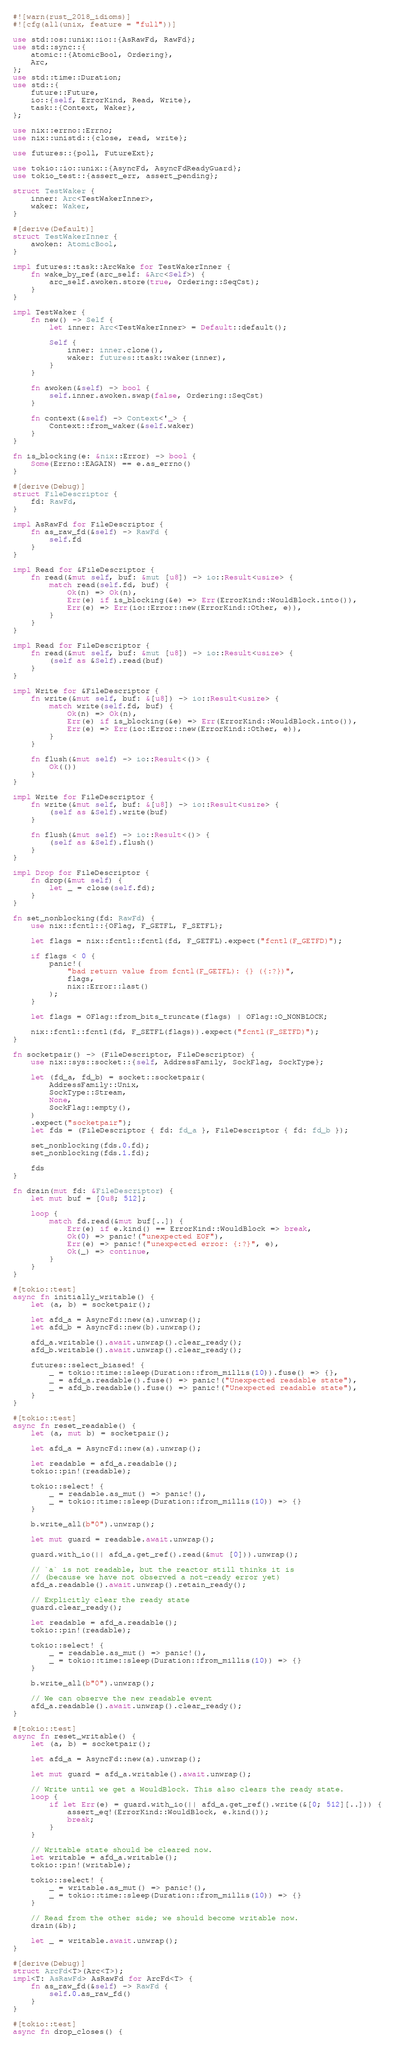Convert code to text. <code><loc_0><loc_0><loc_500><loc_500><_Rust_>#![warn(rust_2018_idioms)]
#![cfg(all(unix, feature = "full"))]

use std::os::unix::io::{AsRawFd, RawFd};
use std::sync::{
    atomic::{AtomicBool, Ordering},
    Arc,
};
use std::time::Duration;
use std::{
    future::Future,
    io::{self, ErrorKind, Read, Write},
    task::{Context, Waker},
};

use nix::errno::Errno;
use nix::unistd::{close, read, write};

use futures::{poll, FutureExt};

use tokio::io::unix::{AsyncFd, AsyncFdReadyGuard};
use tokio_test::{assert_err, assert_pending};

struct TestWaker {
    inner: Arc<TestWakerInner>,
    waker: Waker,
}

#[derive(Default)]
struct TestWakerInner {
    awoken: AtomicBool,
}

impl futures::task::ArcWake for TestWakerInner {
    fn wake_by_ref(arc_self: &Arc<Self>) {
        arc_self.awoken.store(true, Ordering::SeqCst);
    }
}

impl TestWaker {
    fn new() -> Self {
        let inner: Arc<TestWakerInner> = Default::default();

        Self {
            inner: inner.clone(),
            waker: futures::task::waker(inner),
        }
    }

    fn awoken(&self) -> bool {
        self.inner.awoken.swap(false, Ordering::SeqCst)
    }

    fn context(&self) -> Context<'_> {
        Context::from_waker(&self.waker)
    }
}

fn is_blocking(e: &nix::Error) -> bool {
    Some(Errno::EAGAIN) == e.as_errno()
}

#[derive(Debug)]
struct FileDescriptor {
    fd: RawFd,
}

impl AsRawFd for FileDescriptor {
    fn as_raw_fd(&self) -> RawFd {
        self.fd
    }
}

impl Read for &FileDescriptor {
    fn read(&mut self, buf: &mut [u8]) -> io::Result<usize> {
        match read(self.fd, buf) {
            Ok(n) => Ok(n),
            Err(e) if is_blocking(&e) => Err(ErrorKind::WouldBlock.into()),
            Err(e) => Err(io::Error::new(ErrorKind::Other, e)),
        }
    }
}

impl Read for FileDescriptor {
    fn read(&mut self, buf: &mut [u8]) -> io::Result<usize> {
        (self as &Self).read(buf)
    }
}

impl Write for &FileDescriptor {
    fn write(&mut self, buf: &[u8]) -> io::Result<usize> {
        match write(self.fd, buf) {
            Ok(n) => Ok(n),
            Err(e) if is_blocking(&e) => Err(ErrorKind::WouldBlock.into()),
            Err(e) => Err(io::Error::new(ErrorKind::Other, e)),
        }
    }

    fn flush(&mut self) -> io::Result<()> {
        Ok(())
    }
}

impl Write for FileDescriptor {
    fn write(&mut self, buf: &[u8]) -> io::Result<usize> {
        (self as &Self).write(buf)
    }

    fn flush(&mut self) -> io::Result<()> {
        (self as &Self).flush()
    }
}

impl Drop for FileDescriptor {
    fn drop(&mut self) {
        let _ = close(self.fd);
    }
}

fn set_nonblocking(fd: RawFd) {
    use nix::fcntl::{OFlag, F_GETFL, F_SETFL};

    let flags = nix::fcntl::fcntl(fd, F_GETFL).expect("fcntl(F_GETFD)");

    if flags < 0 {
        panic!(
            "bad return value from fcntl(F_GETFL): {} ({:?})",
            flags,
            nix::Error::last()
        );
    }

    let flags = OFlag::from_bits_truncate(flags) | OFlag::O_NONBLOCK;

    nix::fcntl::fcntl(fd, F_SETFL(flags)).expect("fcntl(F_SETFD)");
}

fn socketpair() -> (FileDescriptor, FileDescriptor) {
    use nix::sys::socket::{self, AddressFamily, SockFlag, SockType};

    let (fd_a, fd_b) = socket::socketpair(
        AddressFamily::Unix,
        SockType::Stream,
        None,
        SockFlag::empty(),
    )
    .expect("socketpair");
    let fds = (FileDescriptor { fd: fd_a }, FileDescriptor { fd: fd_b });

    set_nonblocking(fds.0.fd);
    set_nonblocking(fds.1.fd);

    fds
}

fn drain(mut fd: &FileDescriptor) {
    let mut buf = [0u8; 512];

    loop {
        match fd.read(&mut buf[..]) {
            Err(e) if e.kind() == ErrorKind::WouldBlock => break,
            Ok(0) => panic!("unexpected EOF"),
            Err(e) => panic!("unexpected error: {:?}", e),
            Ok(_) => continue,
        }
    }
}

#[tokio::test]
async fn initially_writable() {
    let (a, b) = socketpair();

    let afd_a = AsyncFd::new(a).unwrap();
    let afd_b = AsyncFd::new(b).unwrap();

    afd_a.writable().await.unwrap().clear_ready();
    afd_b.writable().await.unwrap().clear_ready();

    futures::select_biased! {
        _ = tokio::time::sleep(Duration::from_millis(10)).fuse() => {},
        _ = afd_a.readable().fuse() => panic!("Unexpected readable state"),
        _ = afd_b.readable().fuse() => panic!("Unexpected readable state"),
    }
}

#[tokio::test]
async fn reset_readable() {
    let (a, mut b) = socketpair();

    let afd_a = AsyncFd::new(a).unwrap();

    let readable = afd_a.readable();
    tokio::pin!(readable);

    tokio::select! {
        _ = readable.as_mut() => panic!(),
        _ = tokio::time::sleep(Duration::from_millis(10)) => {}
    }

    b.write_all(b"0").unwrap();

    let mut guard = readable.await.unwrap();

    guard.with_io(|| afd_a.get_ref().read(&mut [0])).unwrap();

    // `a` is not readable, but the reactor still thinks it is
    // (because we have not observed a not-ready error yet)
    afd_a.readable().await.unwrap().retain_ready();

    // Explicitly clear the ready state
    guard.clear_ready();

    let readable = afd_a.readable();
    tokio::pin!(readable);

    tokio::select! {
        _ = readable.as_mut() => panic!(),
        _ = tokio::time::sleep(Duration::from_millis(10)) => {}
    }

    b.write_all(b"0").unwrap();

    // We can observe the new readable event
    afd_a.readable().await.unwrap().clear_ready();
}

#[tokio::test]
async fn reset_writable() {
    let (a, b) = socketpair();

    let afd_a = AsyncFd::new(a).unwrap();

    let mut guard = afd_a.writable().await.unwrap();

    // Write until we get a WouldBlock. This also clears the ready state.
    loop {
        if let Err(e) = guard.with_io(|| afd_a.get_ref().write(&[0; 512][..])) {
            assert_eq!(ErrorKind::WouldBlock, e.kind());
            break;
        }
    }

    // Writable state should be cleared now.
    let writable = afd_a.writable();
    tokio::pin!(writable);

    tokio::select! {
        _ = writable.as_mut() => panic!(),
        _ = tokio::time::sleep(Duration::from_millis(10)) => {}
    }

    // Read from the other side; we should become writable now.
    drain(&b);

    let _ = writable.await.unwrap();
}

#[derive(Debug)]
struct ArcFd<T>(Arc<T>);
impl<T: AsRawFd> AsRawFd for ArcFd<T> {
    fn as_raw_fd(&self) -> RawFd {
        self.0.as_raw_fd()
    }
}

#[tokio::test]
async fn drop_closes() {</code> 